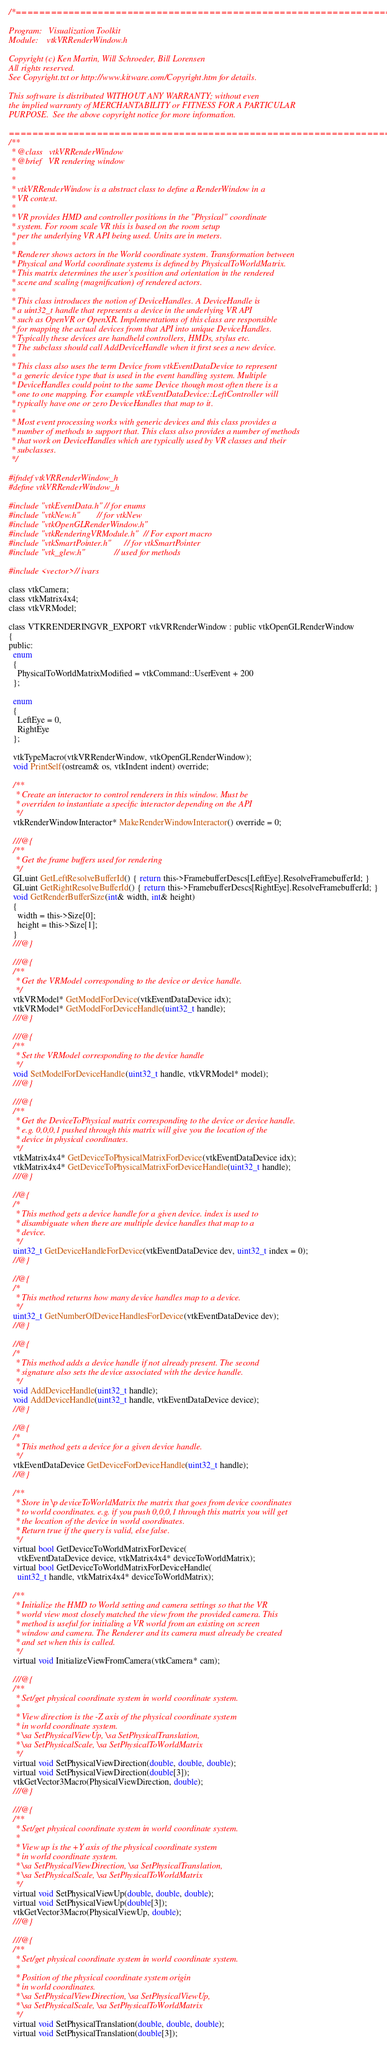Convert code to text. <code><loc_0><loc_0><loc_500><loc_500><_C_>/*=========================================================================

Program:   Visualization Toolkit
Module:    vtkVRRenderWindow.h

Copyright (c) Ken Martin, Will Schroeder, Bill Lorensen
All rights reserved.
See Copyright.txt or http://www.kitware.com/Copyright.htm for details.

This software is distributed WITHOUT ANY WARRANTY; without even
the implied warranty of MERCHANTABILITY or FITNESS FOR A PARTICULAR
PURPOSE.  See the above copyright notice for more information.

=========================================================================*/
/**
 * @class   vtkVRRenderWindow
 * @brief   VR rendering window
 *
 *
 * vtkVRRenderWindow is a abstract class to define a RenderWindow in a
 * VR context.
 *
 * VR provides HMD and controller positions in the "Physical" coordinate
 * system. For room scale VR this is based on the room setup
 * per the underlying VR API being used. Units are in meters.
 *
 * Renderer shows actors in the World coordinate system. Transformation between
 * Physical and World coordinate systems is defined by PhysicalToWorldMatrix.
 * This matrix determines the user's position and orientation in the rendered
 * scene and scaling (magnification) of rendered actors.
 *
 * This class introduces the notion of DeviceHandles. A DeviceHandle is
 * a uint32_t handle that represents a device in the underlying VR API
 * such as OpenVR or OpenXR. Implementations of this class are responsible
 * for mapping the actual devices from that API into unique DeviceHandles.
 * Typically these devices are handheld controllers, HMDs, stylus etc.
 * The subclass should call AddDeviceHandle when it first sees a new device.
 *
 * This class also uses the term Device from vtkEventDataDevice to represent
 * a generic device type that is used in the event handling system. Multiple
 * DeviceHandles could point to the same Device though most often there is a
 * one to one mapping. For example vtkEventDataDevice::LeftController will
 * typically have one or zero DeviceHandles that map to it.
 *
 * Most event processing works with generic devices and this class provides a
 * number of methods to support that. This class also provides a number of methods
 * that work on DeviceHandles which are typically used by VR classes and their
 * subclasses.
 */

#ifndef vtkVRRenderWindow_h
#define vtkVRRenderWindow_h

#include "vtkEventData.h" // for enums
#include "vtkNew.h"       // for vtkNew
#include "vtkOpenGLRenderWindow.h"
#include "vtkRenderingVRModule.h" // For export macro
#include "vtkSmartPointer.h"      // for vtkSmartPointer
#include "vtk_glew.h"             // used for methods

#include <vector> // ivars

class vtkCamera;
class vtkMatrix4x4;
class vtkVRModel;

class VTKRENDERINGVR_EXPORT vtkVRRenderWindow : public vtkOpenGLRenderWindow
{
public:
  enum
  {
    PhysicalToWorldMatrixModified = vtkCommand::UserEvent + 200
  };

  enum
  {
    LeftEye = 0,
    RightEye
  };

  vtkTypeMacro(vtkVRRenderWindow, vtkOpenGLRenderWindow);
  void PrintSelf(ostream& os, vtkIndent indent) override;

  /**
   * Create an interactor to control renderers in this window. Must be
   * overriden to instantiate a specific interactor depending on the API
   */
  vtkRenderWindowInteractor* MakeRenderWindowInteractor() override = 0;

  ///@{
  /**
   * Get the frame buffers used for rendering
   */
  GLuint GetLeftResolveBufferId() { return this->FramebufferDescs[LeftEye].ResolveFramebufferId; }
  GLuint GetRightResolveBufferId() { return this->FramebufferDescs[RightEye].ResolveFramebufferId; }
  void GetRenderBufferSize(int& width, int& height)
  {
    width = this->Size[0];
    height = this->Size[1];
  }
  ///@}

  ///@{
  /**
   * Get the VRModel corresponding to the device or device handle.
   */
  vtkVRModel* GetModelForDevice(vtkEventDataDevice idx);
  vtkVRModel* GetModelForDeviceHandle(uint32_t handle);
  ///@}

  ///@{
  /**
   * Set the VRModel corresponding to the device handle
   */
  void SetModelForDeviceHandle(uint32_t handle, vtkVRModel* model);
  ///@}

  ///@{
  /**
   * Get the DeviceToPhysical matrix corresponding to the device or device handle.
   * e.g. 0,0,0,1 pushed through this matrix will give you the location of the
   * device in physical coordinates.
   */
  vtkMatrix4x4* GetDeviceToPhysicalMatrixForDevice(vtkEventDataDevice idx);
  vtkMatrix4x4* GetDeviceToPhysicalMatrixForDeviceHandle(uint32_t handle);
  ///@}

  //@{
  /*
   * This method gets a device handle for a given device. index is used to
   * disambiguate when there are multiple device handles that map to a
   * device.
   */
  uint32_t GetDeviceHandleForDevice(vtkEventDataDevice dev, uint32_t index = 0);
  //@}

  //@{
  /*
   * This method returns how many device handles map to a device.
   */
  uint32_t GetNumberOfDeviceHandlesForDevice(vtkEventDataDevice dev);
  //@}

  //@{
  /*
   * This method adds a device handle if not already present. The second
   * signature also sets the device associated with the device handle.
   */
  void AddDeviceHandle(uint32_t handle);
  void AddDeviceHandle(uint32_t handle, vtkEventDataDevice device);
  //@}

  //@{
  /*
   * This method gets a device for a given device handle.
   */
  vtkEventDataDevice GetDeviceForDeviceHandle(uint32_t handle);
  //@}

  /**
   * Store in \p deviceToWorldMatrix the matrix that goes from device coordinates
   * to world coordinates. e.g. if you push 0,0,0,1 through this matrix you will get
   * the location of the device in world coordinates.
   * Return true if the query is valid, else false.
   */
  virtual bool GetDeviceToWorldMatrixForDevice(
    vtkEventDataDevice device, vtkMatrix4x4* deviceToWorldMatrix);
  virtual bool GetDeviceToWorldMatrixForDeviceHandle(
    uint32_t handle, vtkMatrix4x4* deviceToWorldMatrix);

  /**
   * Initialize the HMD to World setting and camera settings so that the VR
   * world view most closely matched the view from the provided camera. This
   * method is useful for initialing a VR world from an existing on screen
   * window and camera. The Renderer and its camera must already be created
   * and set when this is called.
   */
  virtual void InitializeViewFromCamera(vtkCamera* cam);

  ///@{
  /**
   * Set/get physical coordinate system in world coordinate system.
   *
   * View direction is the -Z axis of the physical coordinate system
   * in world coordinate system.
   * \sa SetPhysicalViewUp, \sa SetPhysicalTranslation,
   * \sa SetPhysicalScale, \sa SetPhysicalToWorldMatrix
   */
  virtual void SetPhysicalViewDirection(double, double, double);
  virtual void SetPhysicalViewDirection(double[3]);
  vtkGetVector3Macro(PhysicalViewDirection, double);
  ///@}

  ///@{
  /**
   * Set/get physical coordinate system in world coordinate system.
   *
   * View up is the +Y axis of the physical coordinate system
   * in world coordinate system.
   * \sa SetPhysicalViewDirection, \sa SetPhysicalTranslation,
   * \sa SetPhysicalScale, \sa SetPhysicalToWorldMatrix
   */
  virtual void SetPhysicalViewUp(double, double, double);
  virtual void SetPhysicalViewUp(double[3]);
  vtkGetVector3Macro(PhysicalViewUp, double);
  ///@}

  ///@{
  /**
   * Set/get physical coordinate system in world coordinate system.
   *
   * Position of the physical coordinate system origin
   * in world coordinates.
   * \sa SetPhysicalViewDirection, \sa SetPhysicalViewUp,
   * \sa SetPhysicalScale, \sa SetPhysicalToWorldMatrix
   */
  virtual void SetPhysicalTranslation(double, double, double);
  virtual void SetPhysicalTranslation(double[3]);</code> 